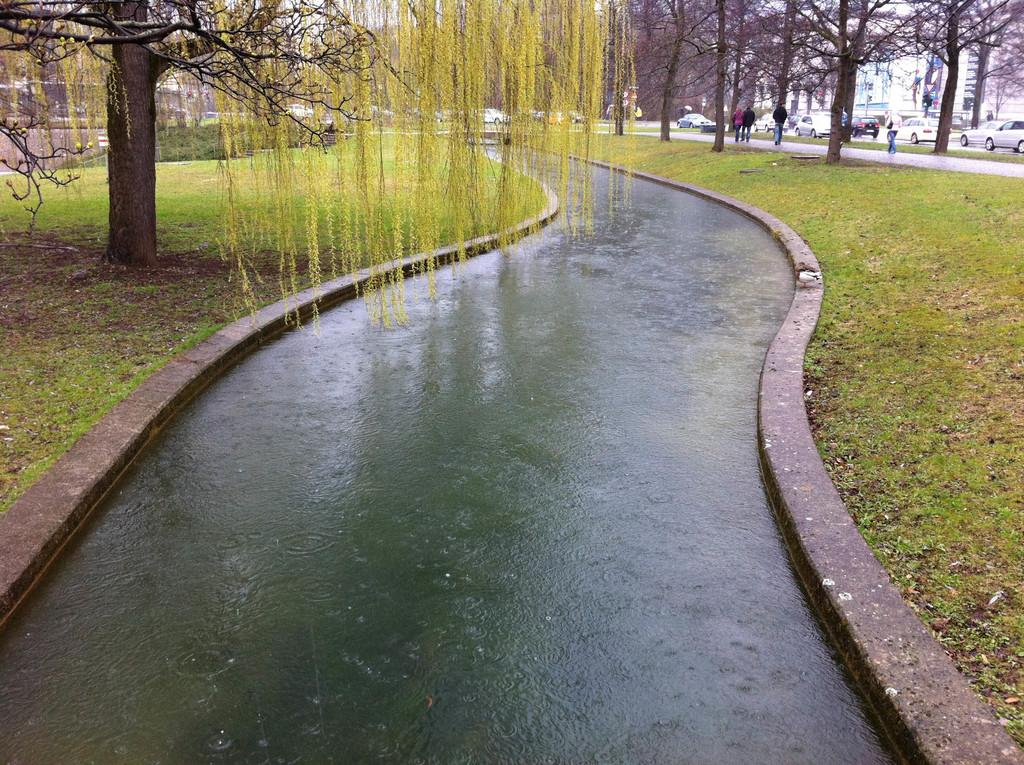What is the main feature in the center of the image? There is water in the center of the image. What type of vegetation is present on either side of the water? There is grass on either side of the water. What other natural elements can be seen in the image? There are trees on either side of the water. Can you describe the people visible in the image? There are people visible in the image, but their specific actions or characteristics are not mentioned in the provided facts. What man-made structures are present in the image? Vehicles and buildings are present in the image. How does the wind affect the finger of the person in the image? There is no mention of a person or their finger in the image, nor is there any indication of wind. 